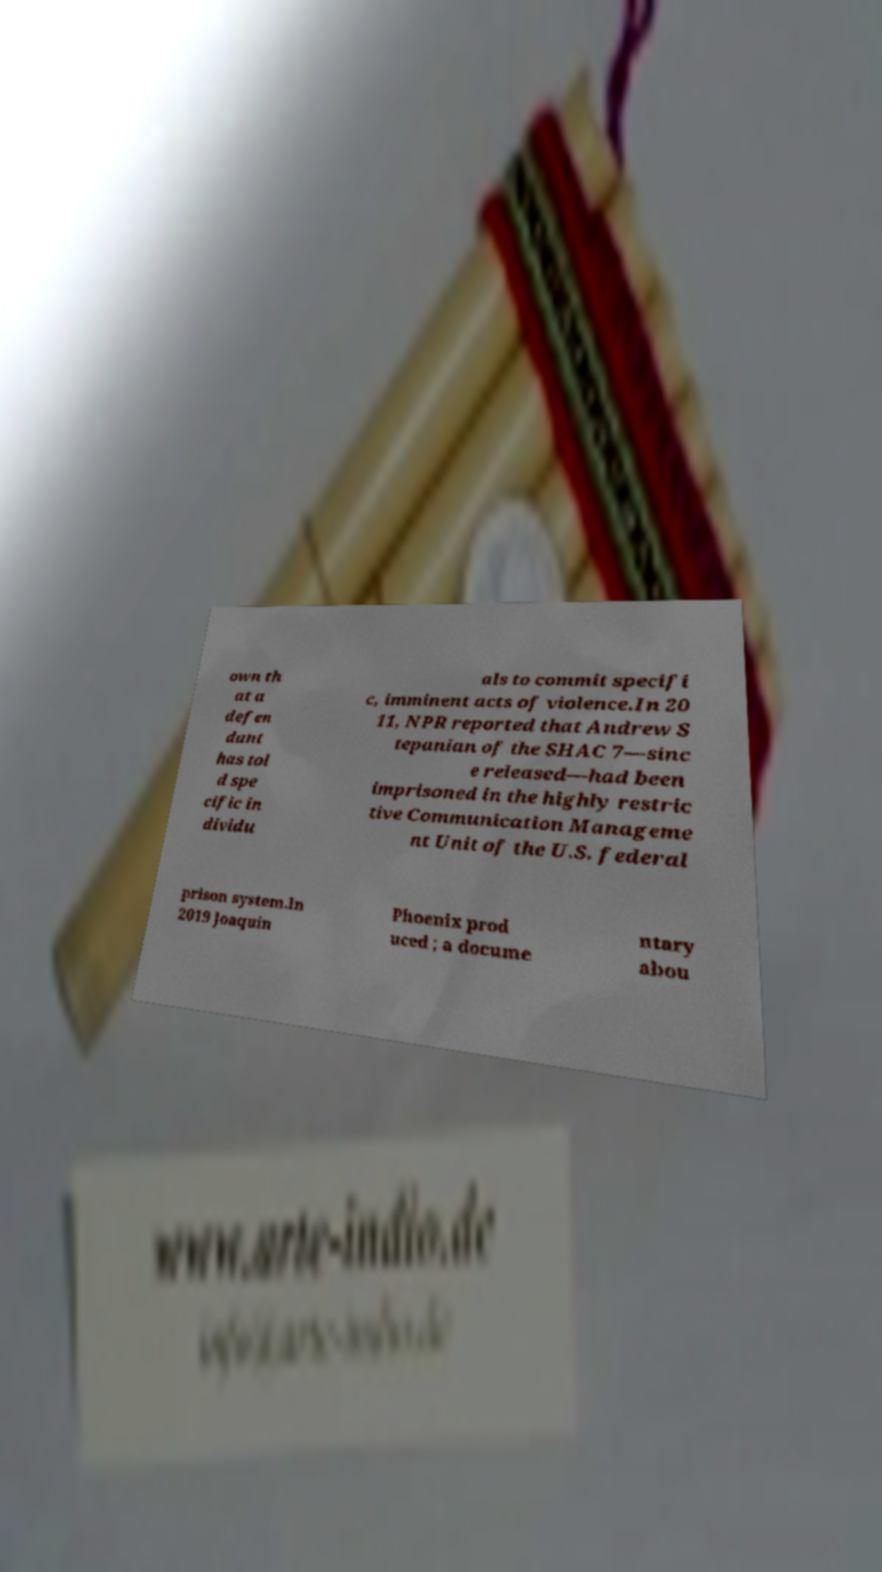Can you accurately transcribe the text from the provided image for me? own th at a defen dant has tol d spe cific in dividu als to commit specifi c, imminent acts of violence.In 20 11, NPR reported that Andrew S tepanian of the SHAC 7—sinc e released—had been imprisoned in the highly restric tive Communication Manageme nt Unit of the U.S. federal prison system.In 2019 Joaquin Phoenix prod uced ; a docume ntary abou 